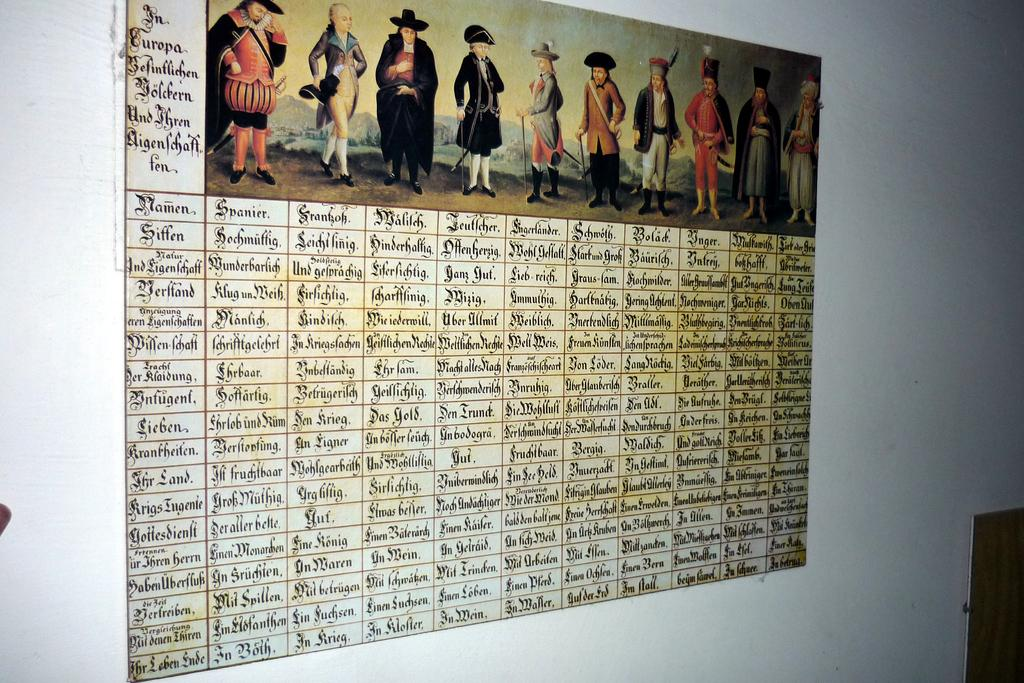What is on the white wall in the image? There is a picture on the white wall in the image. Can you describe the people in the image? There are people in the image, and they are wearing different dresses. What type of club can be seen in the image? There is no club present in the image; it features a picture on a white wall and people wearing different dresses. Can you describe the appearance of the moon in the image? There is no moon present in the image. 